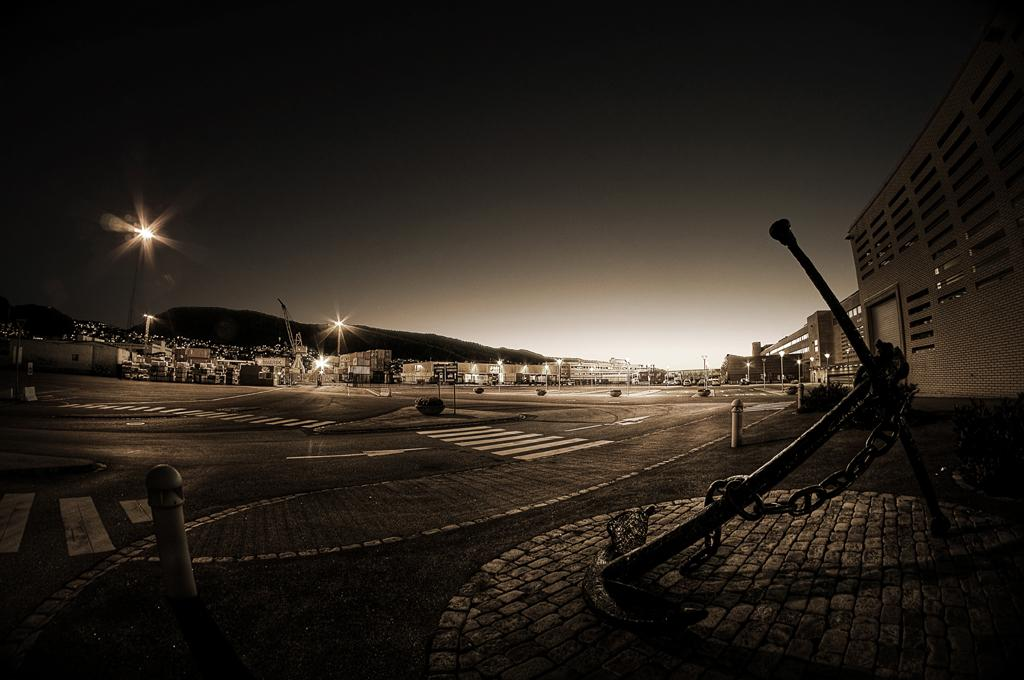What type of objects can be seen in the image that are used for illumination? There are lights in the image. What type of objects can be seen in the image that support the lights? There are poles in the image. What type of objects can be seen in the image that are flat and may have writing or images on them? There are boards in the image. What type of objects can be seen in the image that are long and thin? There are rods in the image. What type of object can be seen in the image that connects two points? There is a chain in the image. What type of surface can be seen in the image that vehicles travel on? There is a road in the image. What type of structures can be seen in the image that people may live or work in? There are buildings in the image. What can be seen in the background of the image? The sky is visible in the background of the image. How many apples can be seen hanging from the rods in the image? There are no apples present in the image; it features lights, poles, boards, rods, a chain, a road, buildings, and a visible sky. Can you describe the worm crawling on the chain in the image? There is no worm present in the image; it features lights, poles, boards, rods, a chain, a road, buildings, and a visible sky. 